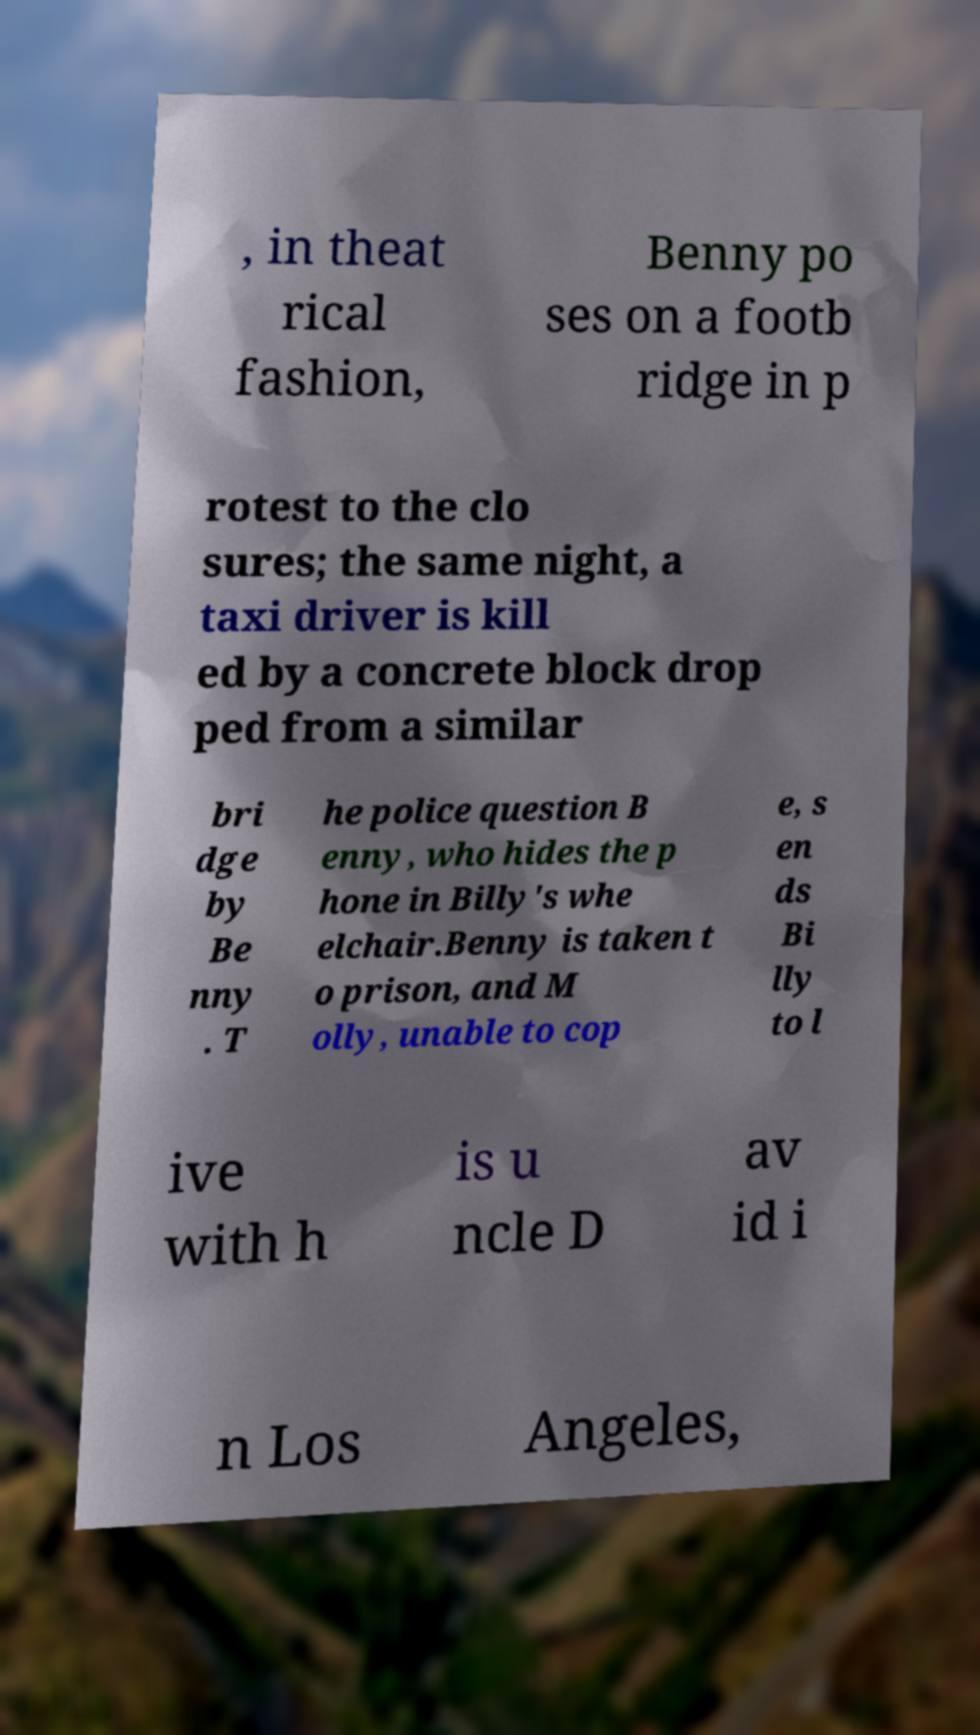What messages or text are displayed in this image? I need them in a readable, typed format. , in theat rical fashion, Benny po ses on a footb ridge in p rotest to the clo sures; the same night, a taxi driver is kill ed by a concrete block drop ped from a similar bri dge by Be nny . T he police question B enny, who hides the p hone in Billy's whe elchair.Benny is taken t o prison, and M olly, unable to cop e, s en ds Bi lly to l ive with h is u ncle D av id i n Los Angeles, 